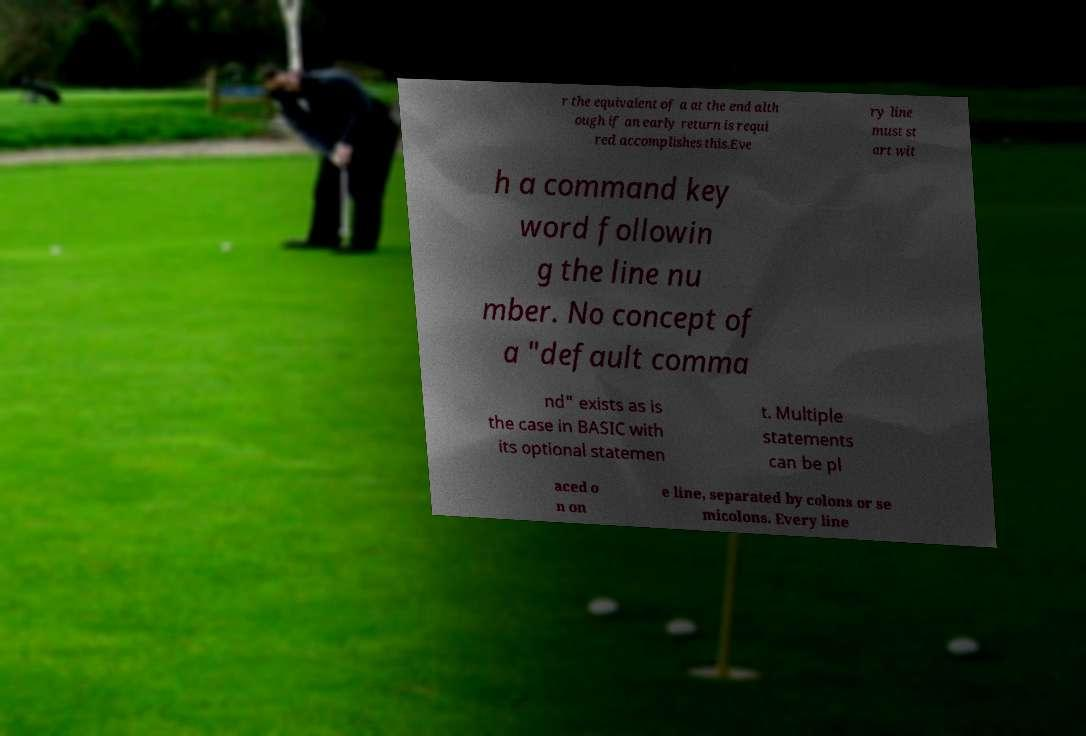There's text embedded in this image that I need extracted. Can you transcribe it verbatim? r the equivalent of a at the end alth ough if an early return is requi red accomplishes this.Eve ry line must st art wit h a command key word followin g the line nu mber. No concept of a "default comma nd" exists as is the case in BASIC with its optional statemen t. Multiple statements can be pl aced o n on e line, separated by colons or se micolons. Every line 